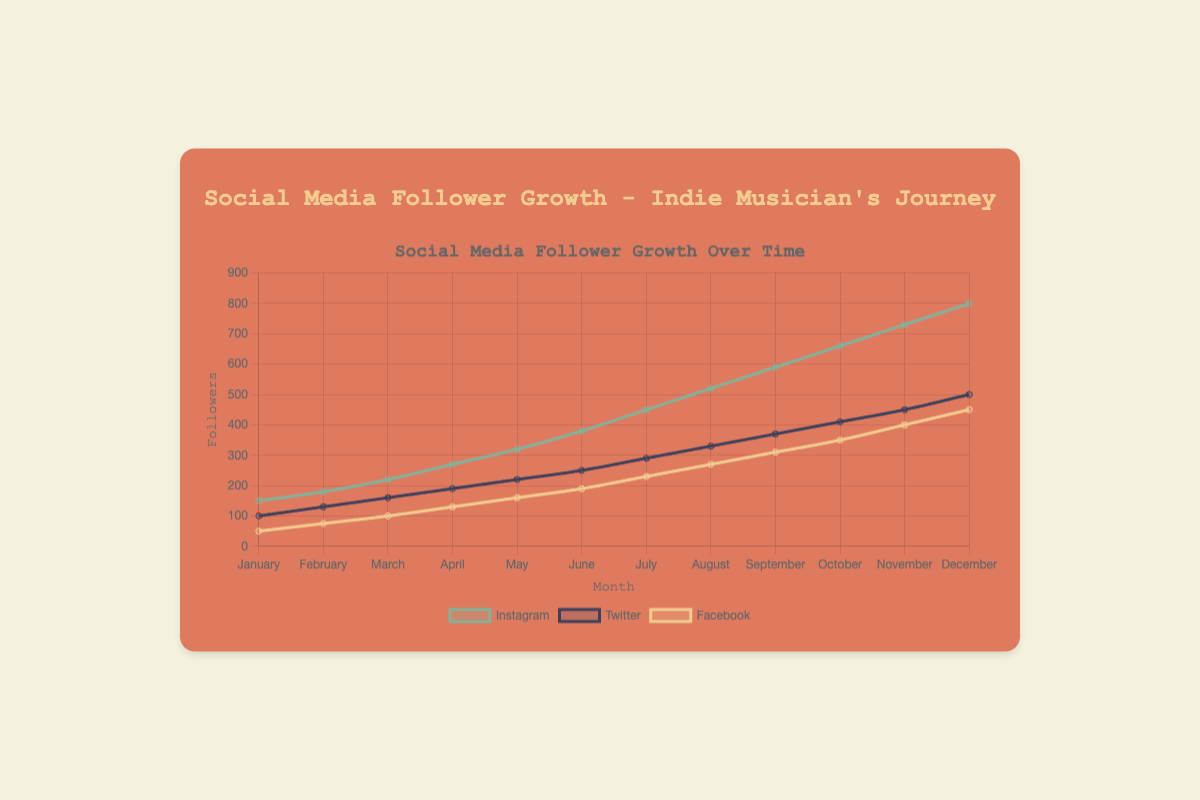How many more followers does Instagram have compared to Twitter in December? In December, Instagram has 800 followers and Twitter has 500 followers. The difference is 800 - 500 = 300.
Answer: 300 Which platform had the highest follower growth from January to December? From January to December, Instagram increased from 150 to 800 followers, Twitter from 100 to 500, and Facebook from 50 to 450. Instagram had the highest growth (800 - 150 = 650).
Answer: Instagram In which month did Facebook followers surpass 200? Looking at the data, Facebook followers surpassed 200 in July when it reached 230 followers.
Answer: July What is the total number of followers across all platforms in November? Summing up November's followers: Instagram (730) + Twitter (450) + Facebook (400) = 730 + 450 + 400 = 1580.
Answer: 1580 Which platform had the steepest increase in followers between two consecutive months, and when was it? The steepest increase was on Instagram between November (730 followers) and December (800 followers), which is a jump of 70 followers.
Answer: Instagram, November to December Between April and May, how many more Instagram followers were gained compared to Facebook followers? Instagram followers increased from 270 to 320 (a gain of 50), and Facebook followers increased from 130 to 160 (a gain of 30). The difference in gains is 50 - 30 = 20.
Answer: 20 During which month did Twitter overtake Facebook in the number of followers for the first time? In January, Twitter had more followers (100) than Facebook (50), so Twitter overtook Facebook from the beginning and consistently had more followers in all months.
Answer: January Compare the growth rates of the platforms from March to April. Instagram grew from 220 to 270 (an increase of 50), Twitter from 160 to 190 (an increase of 30), and Facebook from 100 to 130 (an increase of 30). Instagram had the highest growth rate of 50.
Answer: Instagram By what factor did Instagram's followers grow from January to December? January’s followers were 150 and December's were 800. The growth factor is 800 / 150 = 5.33.
Answer: 5.33 What are the followers' trends for all platforms in the last quarter (October to December)? In October, Instagram had 660, Twitter 410, Facebook 350. In November, Instagram 730, Twitter 450, Facebook 400. In December, Instagram 800, Twitter 500, Facebook 450. All platforms show a steady increase: Instagram (140), Twitter (90), Facebook (100).
Answer: Steady increase 